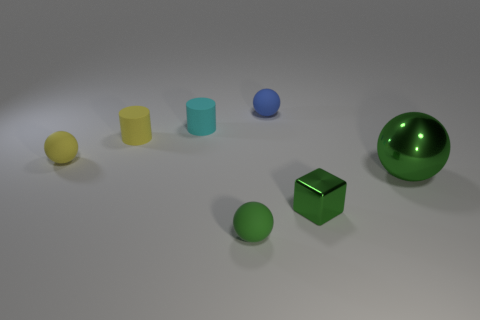Can you describe the shapes and colors of the objects in the image? Certainly! In the image, there's a variety of geometric shapes. Starting from the left, there is a small yellow sphere, followed by a tall yellow cylinder, a shorter cyan cylinder, a small blue sphere, a large green sphere, a small green sphere, and a medium-sized green cube. Each object has a distinct, solid color and a matte finish. 